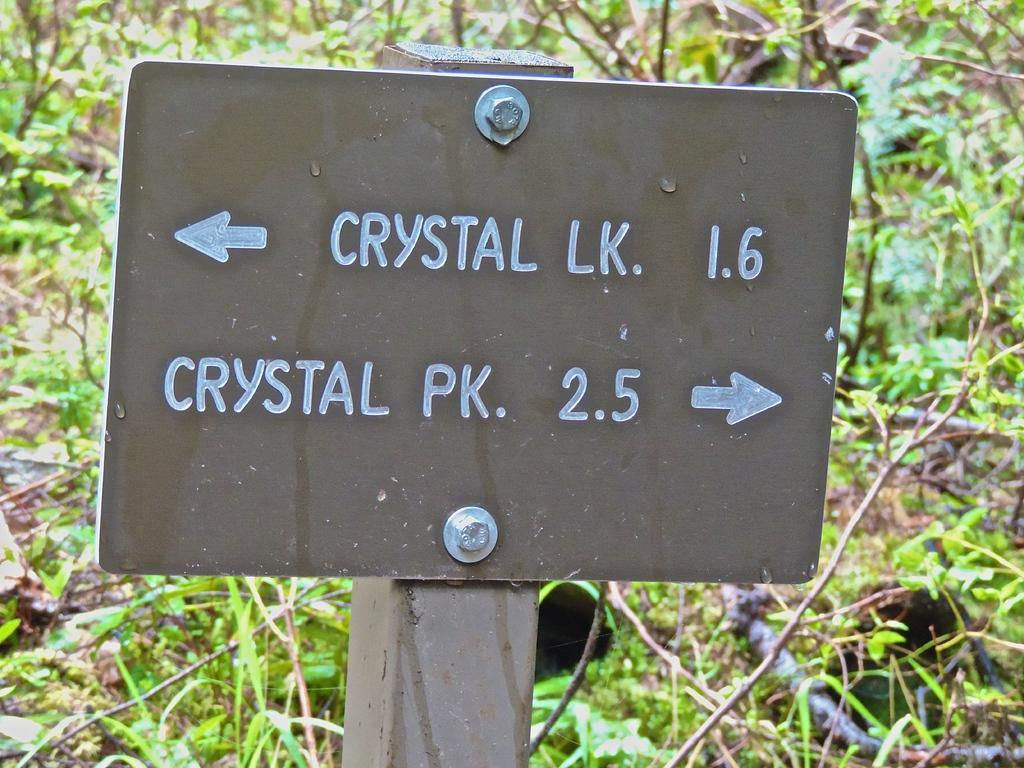What is the main object in the image? There is a display board in the image. How is the display board attached to another surface? The display board is fixed to wood. What type of images can be seen on the board? There are plants depicted on the board. What else can be found on the display board? There is text on the board. How many slaves are depicted on the display board? There are no slaves depicted on the display board; it features plants and text. What type of day is shown on the display board? There is no depiction of a day on the display board; it only contains plants and text. 